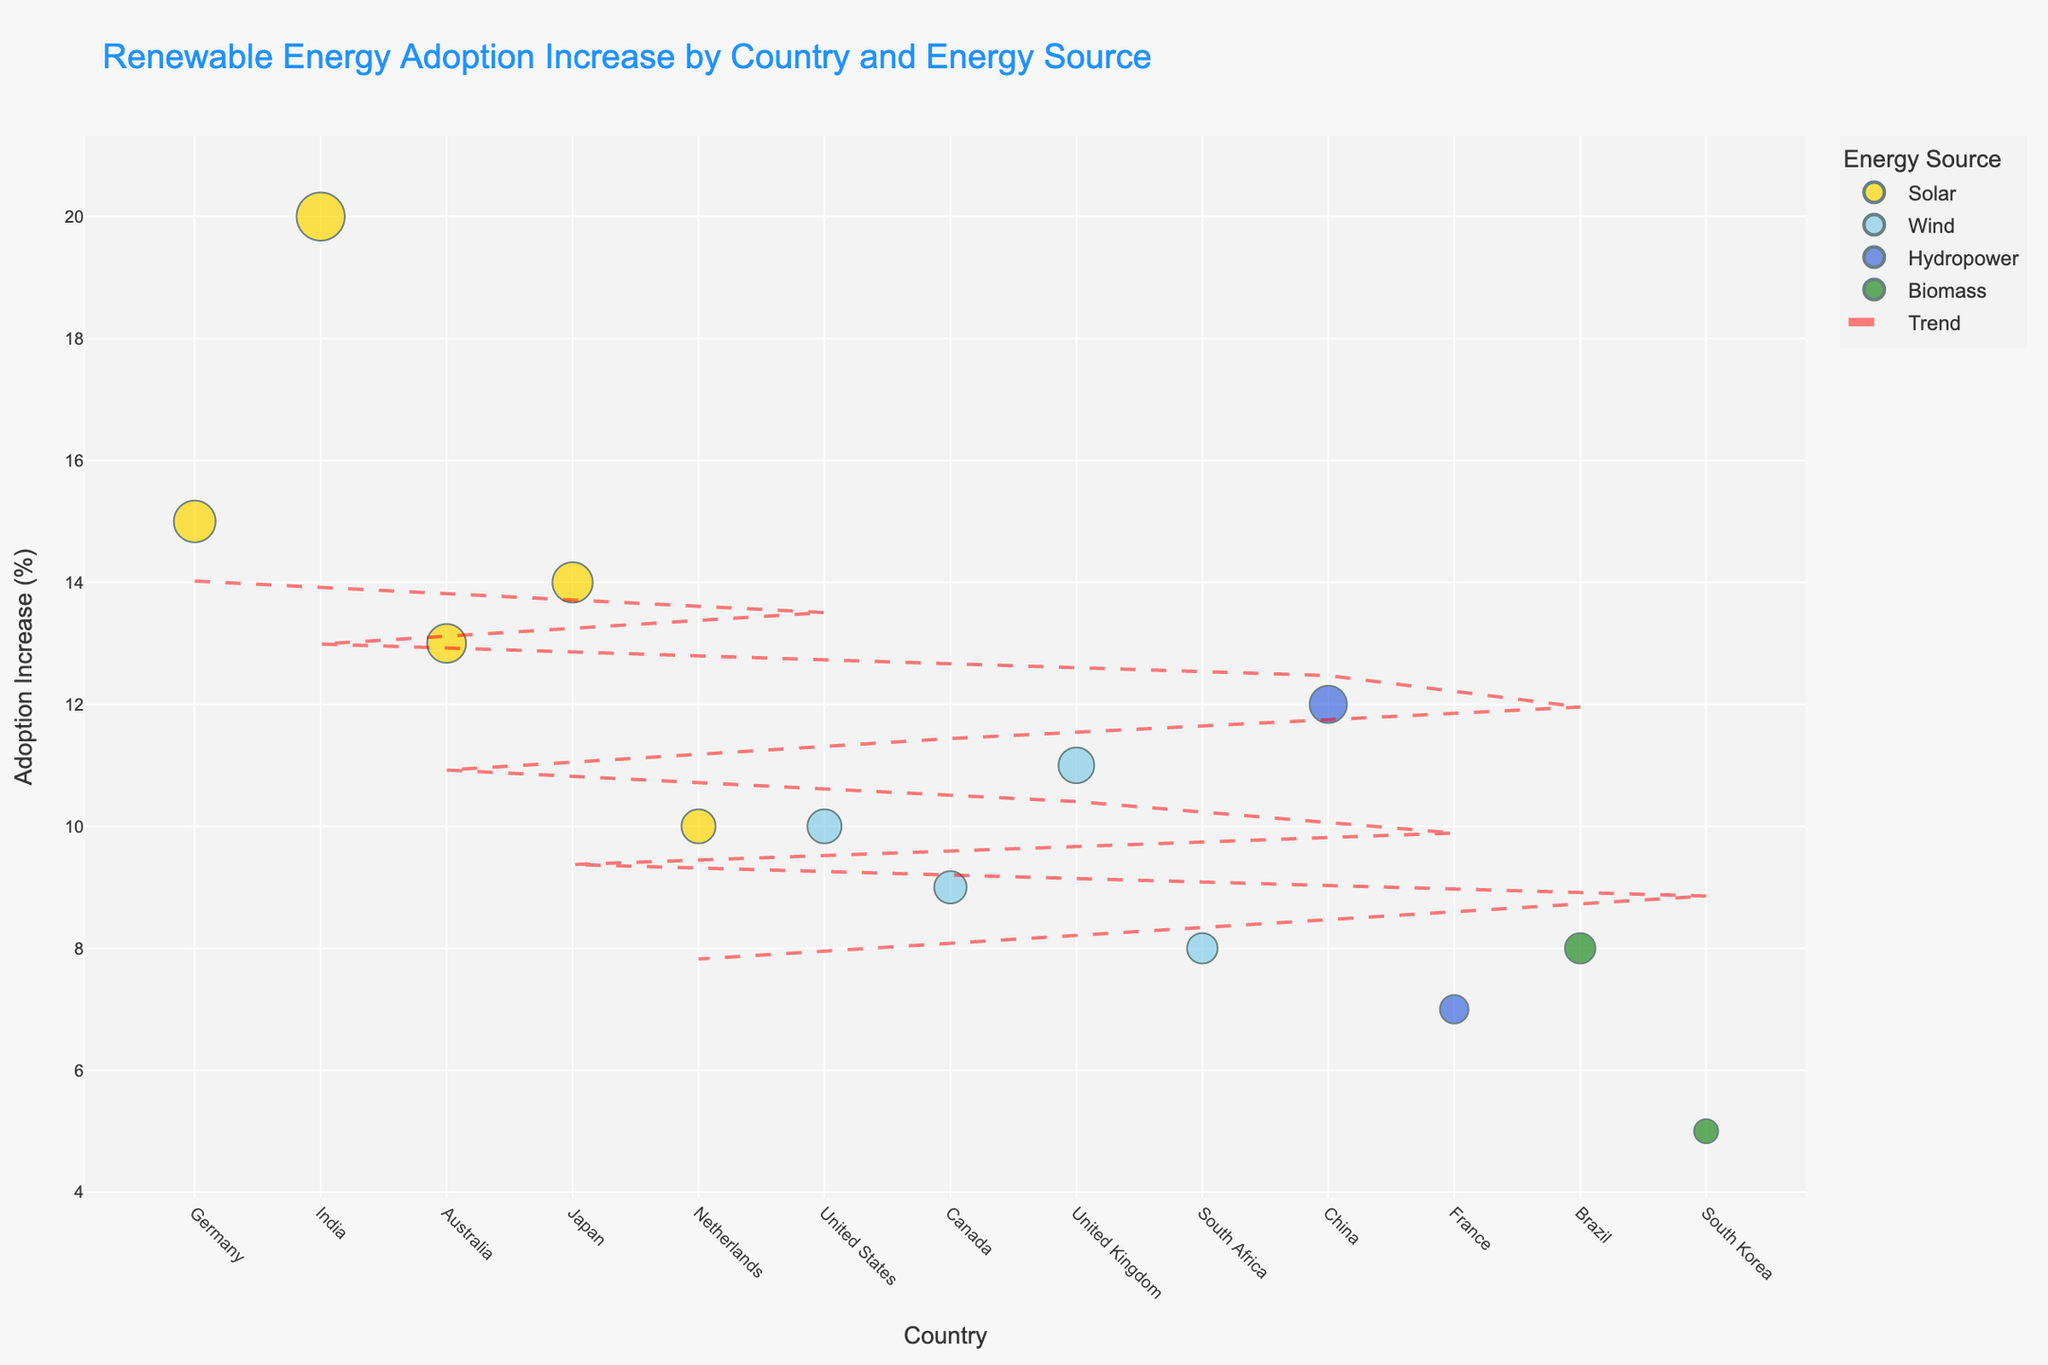what is the title of the chart? The title of the chart is located at the top and reads "Renewable Energy Adoption Increase by Country and Energy Source".
Answer: Renewable Energy Adoption Increase by Country and Energy Source Which country has the highest Increase in Adoption percentage for Solar energy? By looking at the bubbles colored gold (representing Solar energy), India has the largest bubble with an Increase in Adoption percentage of 20%.
Answer: India What positive outlook indicator is associated with Japan's Solar energy adoption bubble? Hover over the gold-colored bubble representing Japan to see additional data, which includes the positive outlook indicator "Hopeful".
Answer: Hopeful How does the Increase in Adoption percentage for Wind energy in the United Kingdom compare to that in the United States? Compare the light blue bubbles representing Wind energy for both countries. The United Kingdom has an 11% increase, while the United States has a 10% increase. Thus, the United Kingdom has a higher increase.
Answer: Higher What is the average Increase in Adoption percentage for countries using Wind energy? Add the percentages for the countries using Wind energy: (10 + 9 + 11 + 8) = 38. Divide by the number of countries (4) to find the average: 38/4 = 9.5
Answer: 9.5 Which energy source has the highest occurrence of "Optimistic" and "Positive" outlook indicators combined? Count the occurrences for each energy source. Solar has "Optimistic" (Germany, India) and "Positive" (Australia, Netherlands): 4 occurrences. Wind has "Optimistic" (South Africa), "Hopeful" (United States), "Promising" (United Kingdom), "Optimistic" (Canada): 4 occurrences. Comparing Solar (4) and Wind (4), both have equal counts of 4 "Optimistic" or "Positive" outlook indicators.
Answer: Solar and Wind Which country represents the lowest Increase in Adoption percentage for Biomass energy, and what is the percentage? By identifying green bubbles for Biomass, South Korea shows the smallest bubble size, indicating the lowest Increase in Adoption percentage at 5%.
Answer: South Korea, 5% What trend does the red dashed line represent on the bubble chart? The red dashed line is a trendline that provides a visual linear fit of the Increase in Adoption percentages across all countries, showing a general trend in the data.
Answer: Overall trend in adoption increase What is the difference in Increase in Adoption percentages between China and Brazil for Hydropower and Biomass respectively? China's Hydropower increase is 12%, and Brazil's Biomass increase is 8%. The difference is: 12 - 8 = 4
Answer: 4 How many countries have an Increase in Adoption percentage greater than 10%? Identify bubbles with percentages exceeding 10%. Germany (15%), India (20%), Australia (13%), Japan (14%), United Kingdom (11%). There are 5 countries with adoption increases greater than 10%.
Answer: 5 